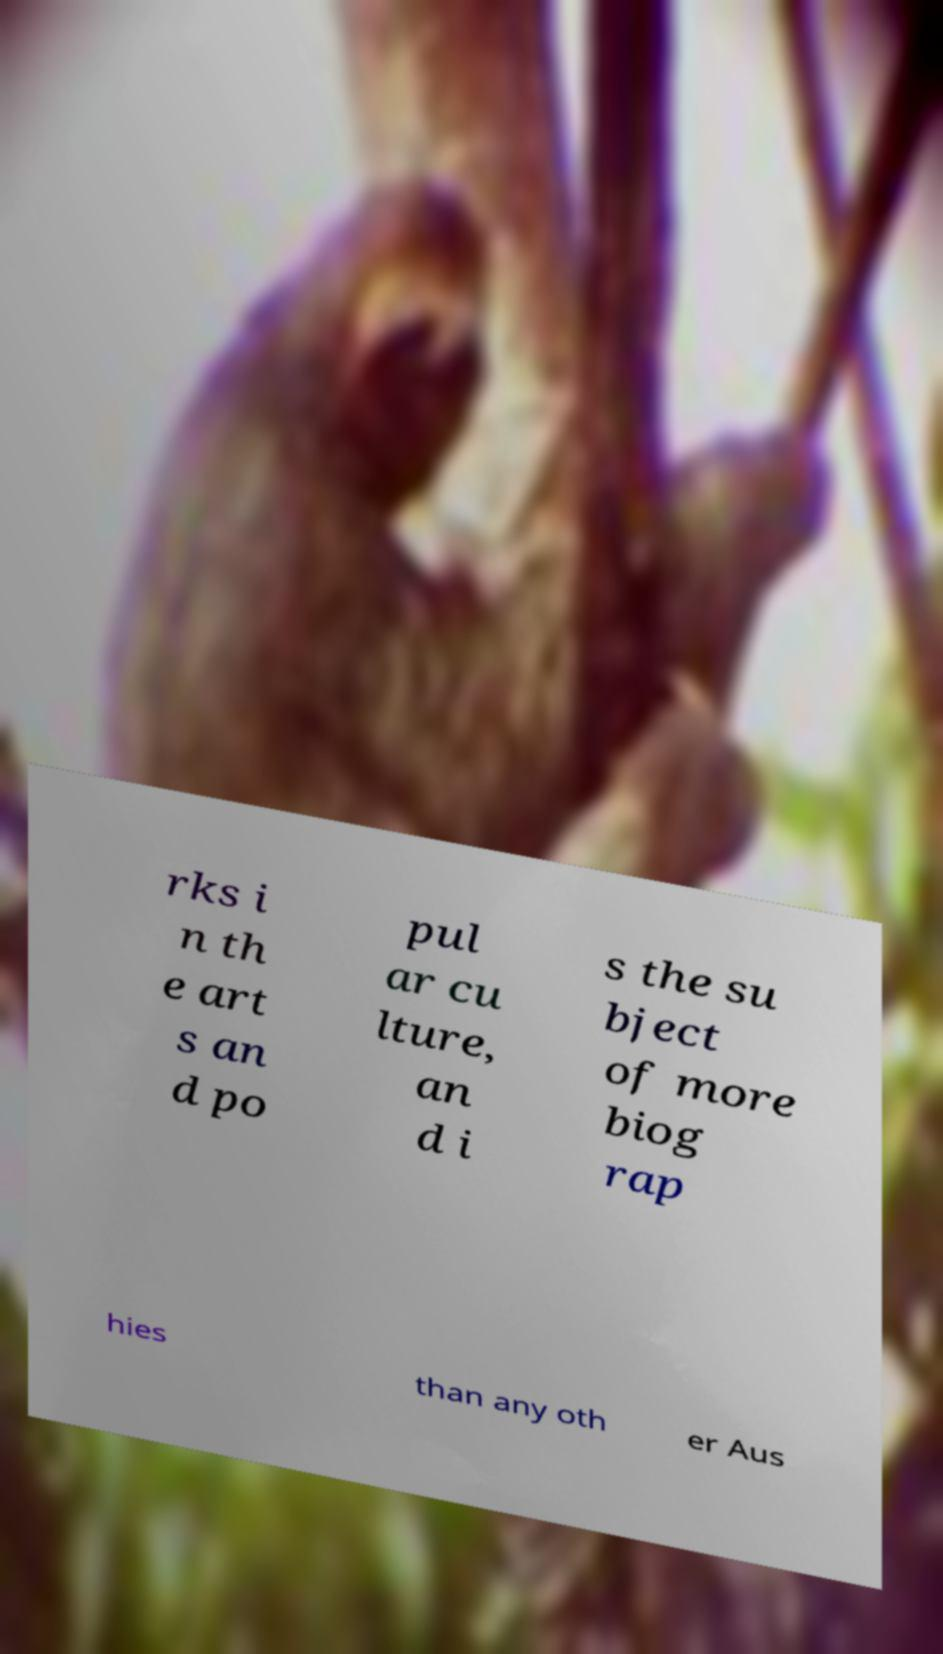I need the written content from this picture converted into text. Can you do that? rks i n th e art s an d po pul ar cu lture, an d i s the su bject of more biog rap hies than any oth er Aus 